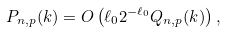Convert formula to latex. <formula><loc_0><loc_0><loc_500><loc_500>P _ { n , p } ( k ) = O \left ( \ell _ { 0 } 2 ^ { - \ell _ { 0 } } Q _ { n , p } ( k ) \right ) ,</formula> 